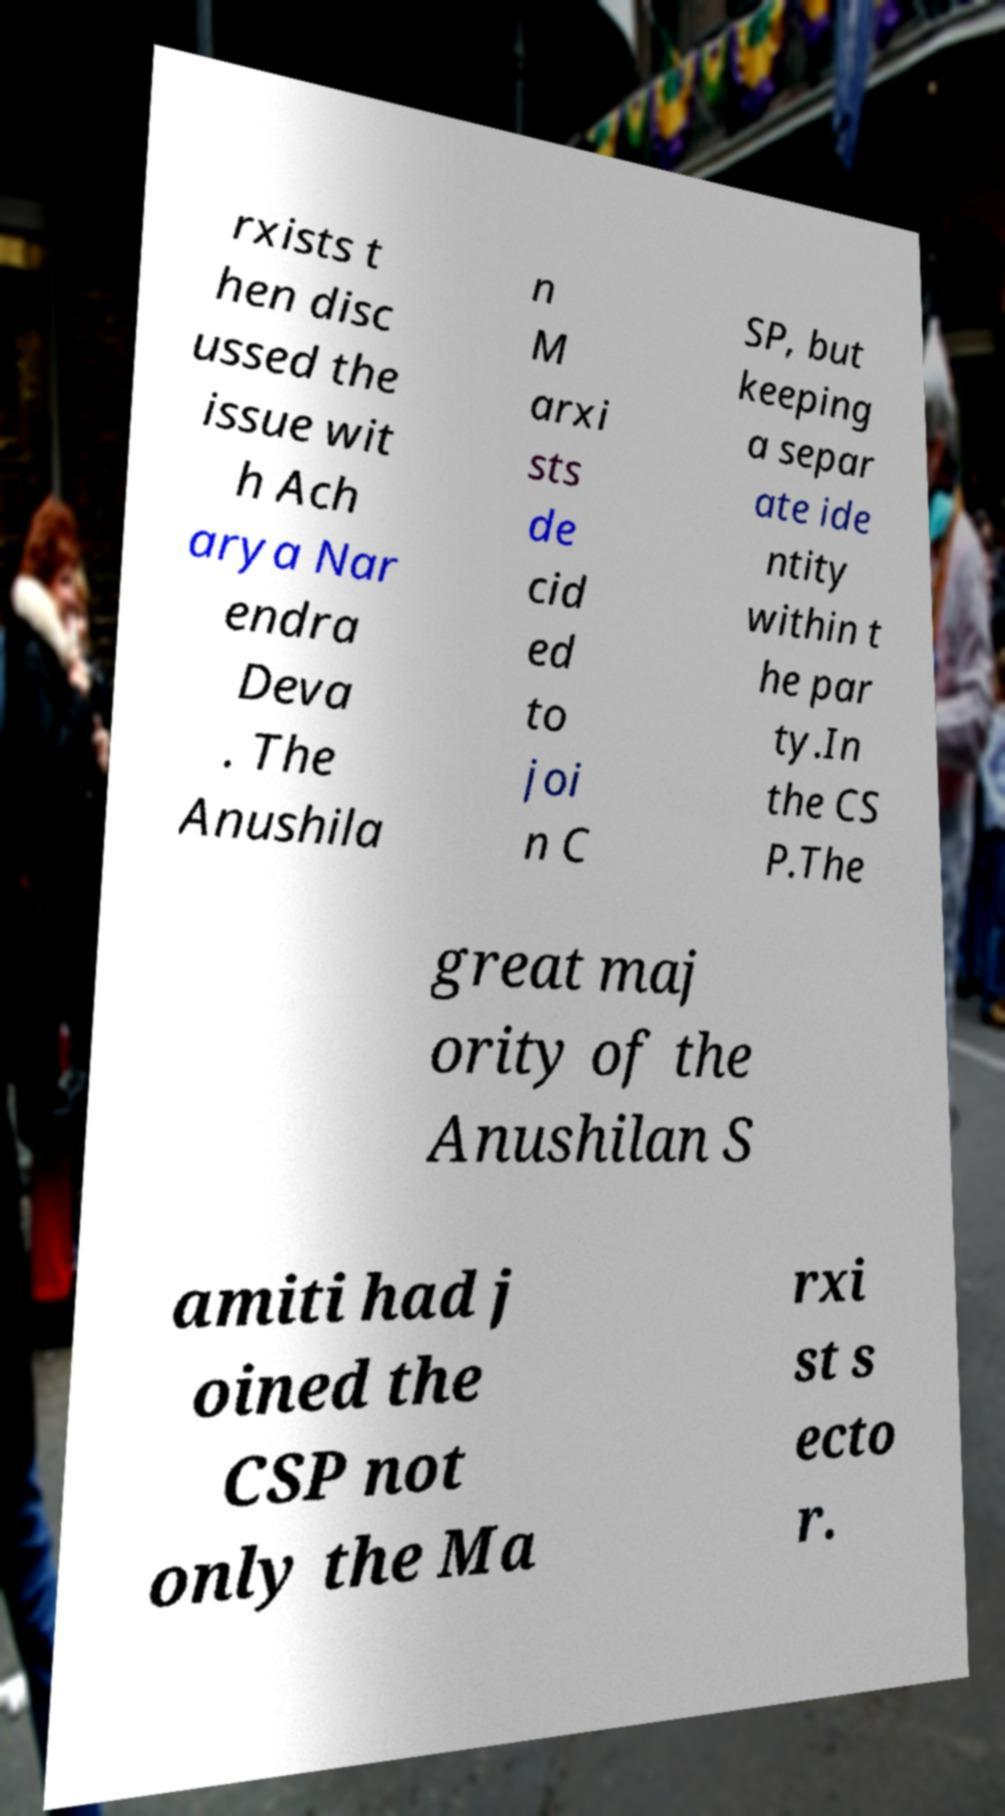Please identify and transcribe the text found in this image. rxists t hen disc ussed the issue wit h Ach arya Nar endra Deva . The Anushila n M arxi sts de cid ed to joi n C SP, but keeping a separ ate ide ntity within t he par ty.In the CS P.The great maj ority of the Anushilan S amiti had j oined the CSP not only the Ma rxi st s ecto r. 